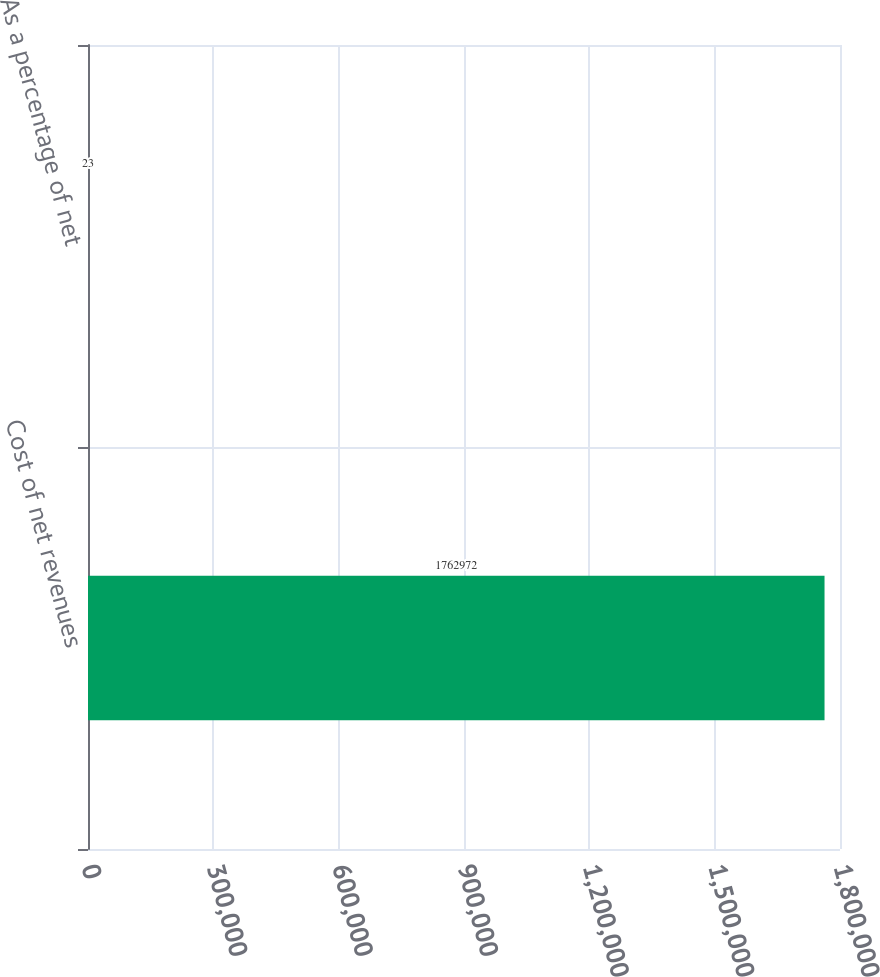<chart> <loc_0><loc_0><loc_500><loc_500><bar_chart><fcel>Cost of net revenues<fcel>As a percentage of net<nl><fcel>1.76297e+06<fcel>23<nl></chart> 